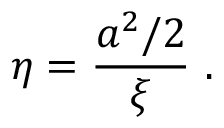<formula> <loc_0><loc_0><loc_500><loc_500>\eta = { \frac { a ^ { 2 } / 2 } { \xi } } \ .</formula> 